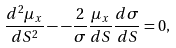<formula> <loc_0><loc_0><loc_500><loc_500>\frac { d ^ { 2 } \mu _ { x } } { d S ^ { 2 } } - - \frac { 2 } { \sigma } \frac { \mu _ { x } } { d S } \frac { d \sigma } { d S } = 0 ,</formula> 